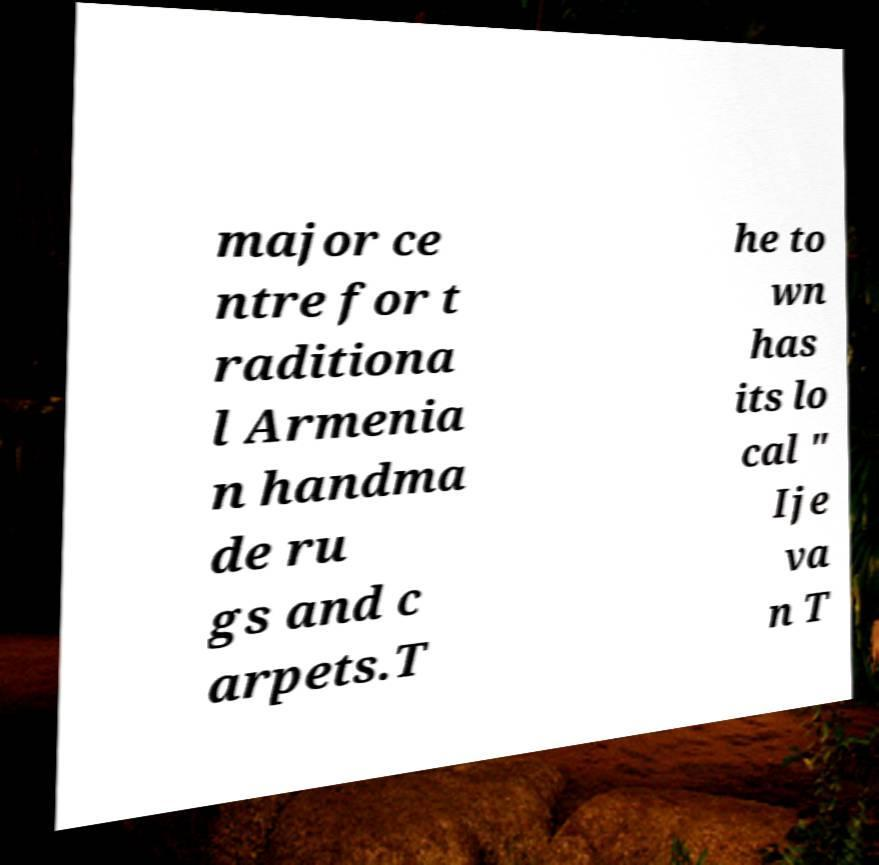Please identify and transcribe the text found in this image. major ce ntre for t raditiona l Armenia n handma de ru gs and c arpets.T he to wn has its lo cal " Ije va n T 